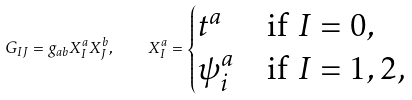Convert formula to latex. <formula><loc_0><loc_0><loc_500><loc_500>G _ { I J } = g _ { a b } X ^ { a } _ { I } X ^ { b } _ { J } , \quad X _ { I } ^ { a } = \begin{cases} t ^ { a } & \text {if $I=0$} , \\ \psi _ { i } ^ { a } & \text {if $I=1,2$,} \end{cases}</formula> 